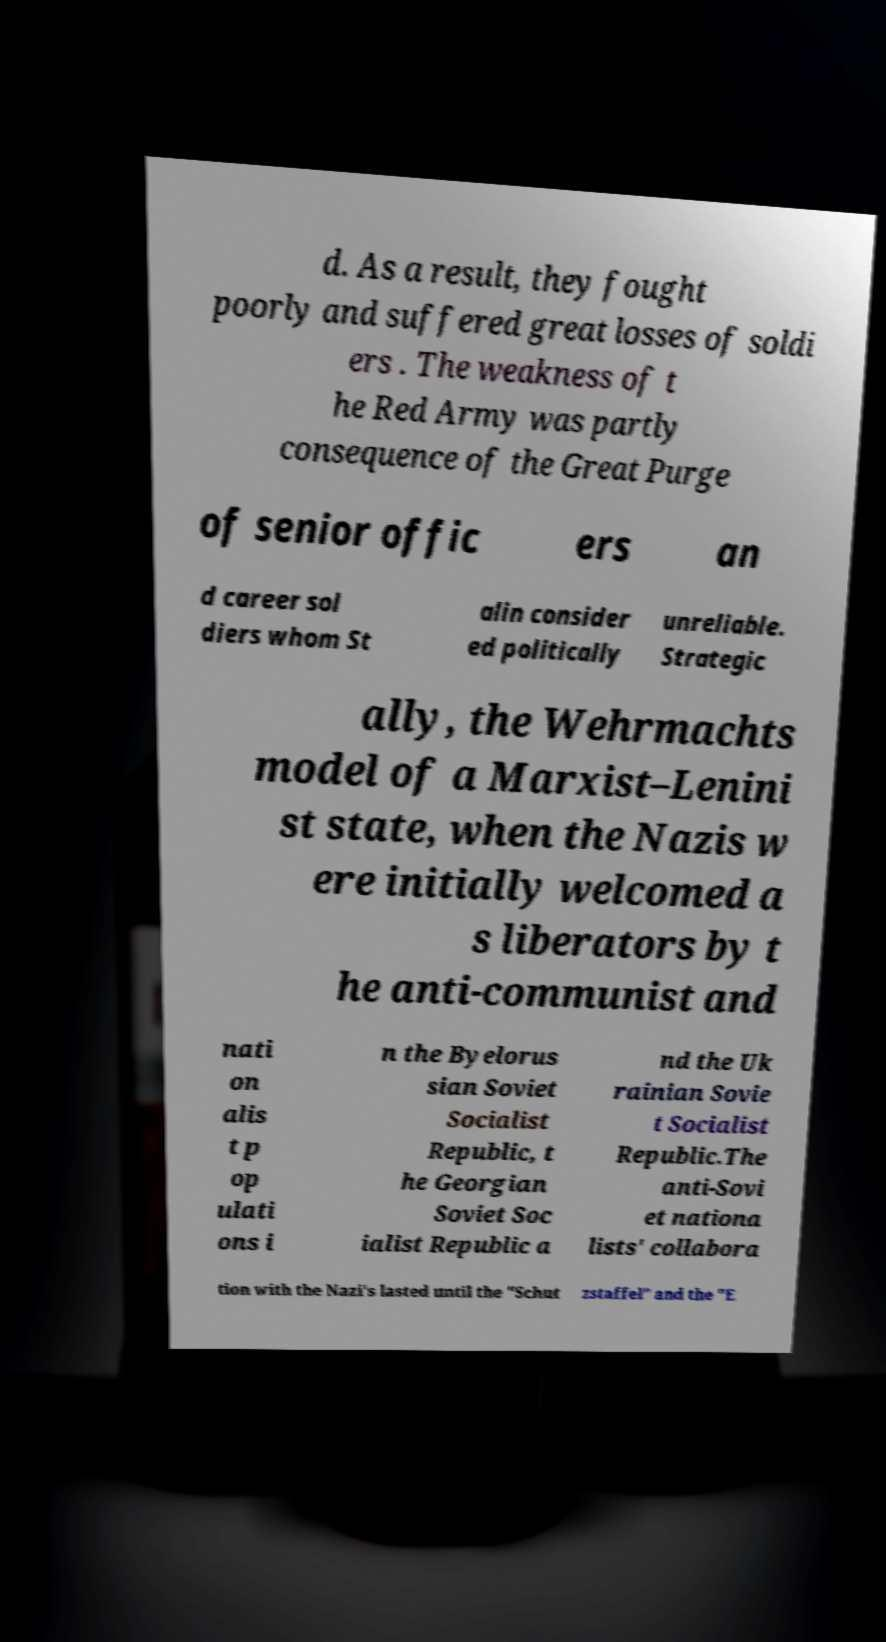Could you assist in decoding the text presented in this image and type it out clearly? d. As a result, they fought poorly and suffered great losses of soldi ers . The weakness of t he Red Army was partly consequence of the Great Purge of senior offic ers an d career sol diers whom St alin consider ed politically unreliable. Strategic ally, the Wehrmachts model of a Marxist–Lenini st state, when the Nazis w ere initially welcomed a s liberators by t he anti-communist and nati on alis t p op ulati ons i n the Byelorus sian Soviet Socialist Republic, t he Georgian Soviet Soc ialist Republic a nd the Uk rainian Sovie t Socialist Republic.The anti-Sovi et nationa lists' collabora tion with the Nazi's lasted until the "Schut zstaffel" and the "E 